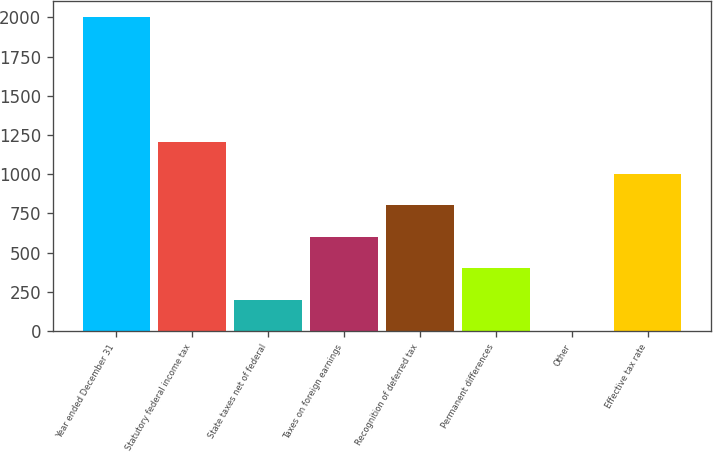<chart> <loc_0><loc_0><loc_500><loc_500><bar_chart><fcel>Year ended December 31<fcel>Statutory federal income tax<fcel>State taxes net of federal<fcel>Taxes on foreign earnings<fcel>Recognition of deferred tax<fcel>Permanent differences<fcel>Other<fcel>Effective tax rate<nl><fcel>2005<fcel>1203.44<fcel>201.49<fcel>602.27<fcel>802.66<fcel>401.88<fcel>1.1<fcel>1003.05<nl></chart> 